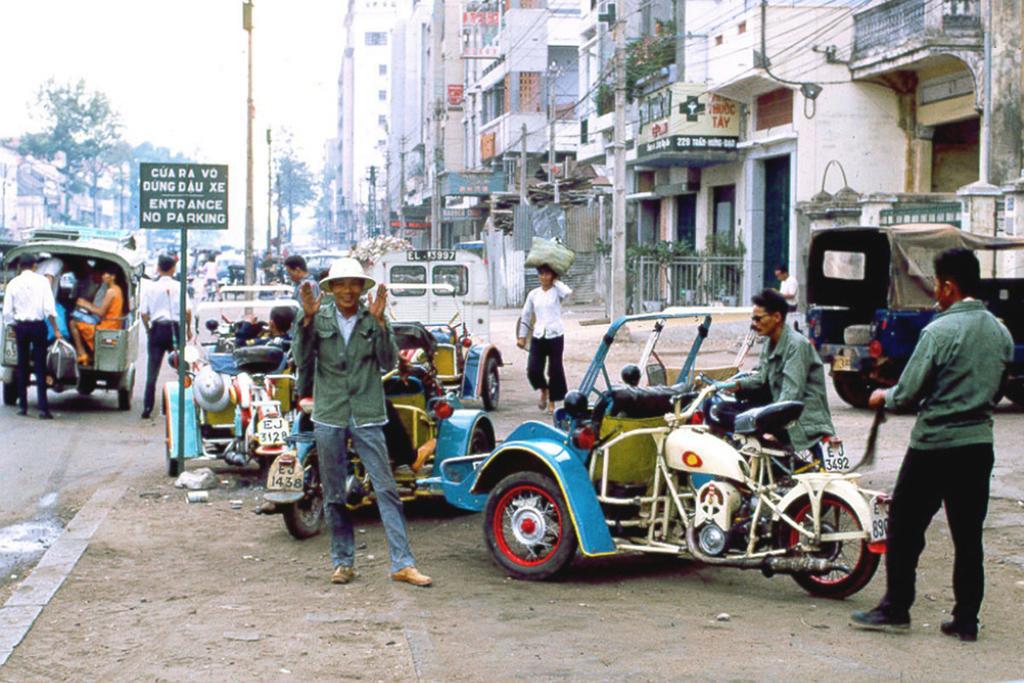Can you describe this image briefly? The image was taken on a street over the right side corner there are buildings,over left side its a road and in the middle there are motorcycles and some men standing ,and there is a sign board in the middle,along with them there are street poles over the left side there are some trees and passengers getting into auto rickshaw on the left side. 